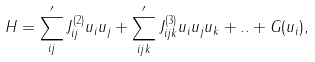<formula> <loc_0><loc_0><loc_500><loc_500>H = \sum _ { i j } ^ { \prime } J ^ { ( 2 ) } _ { i j } { u _ { i } } u _ { j } + \sum _ { i j k } ^ { \prime } J ^ { ( 3 ) } _ { i j k } { u _ { i } } { u _ { j } } { u _ { k } } + . . + G ( u _ { i } ) ,</formula> 